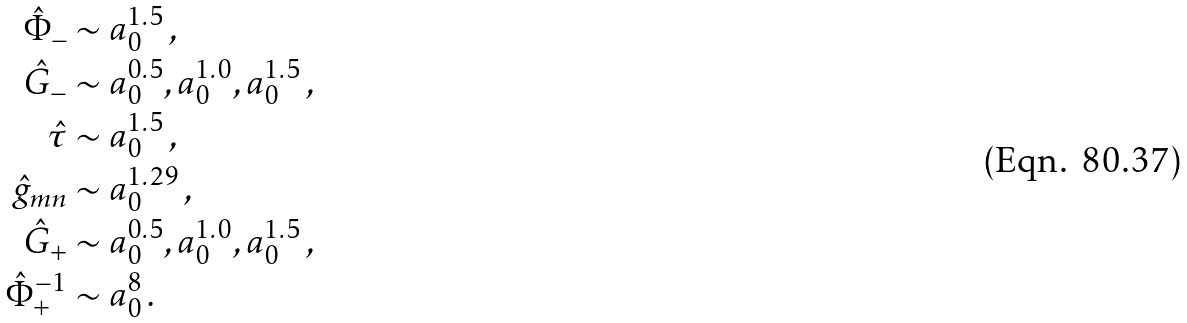Convert formula to latex. <formula><loc_0><loc_0><loc_500><loc_500>\hat { \Phi } _ { - } & \sim a _ { 0 } ^ { 1 . 5 } \, , \\ \hat { G } _ { - } & \sim a _ { 0 } ^ { 0 . 5 } , a _ { 0 } ^ { 1 . 0 } , a _ { 0 } ^ { 1 . 5 } \, , \\ \hat { \tau } & \sim a _ { 0 } ^ { 1 . 5 } \, , \\ \hat { g } _ { m n } & \sim a _ { 0 } ^ { 1 . 2 9 } \, , \\ \hat { G } _ { + } & \sim a _ { 0 } ^ { 0 . 5 } , a _ { 0 } ^ { 1 . 0 } , a _ { 0 } ^ { 1 . 5 } \, , \\ \hat { \Phi } _ { + } ^ { - 1 } & \sim a _ { 0 } ^ { 8 } \, .</formula> 